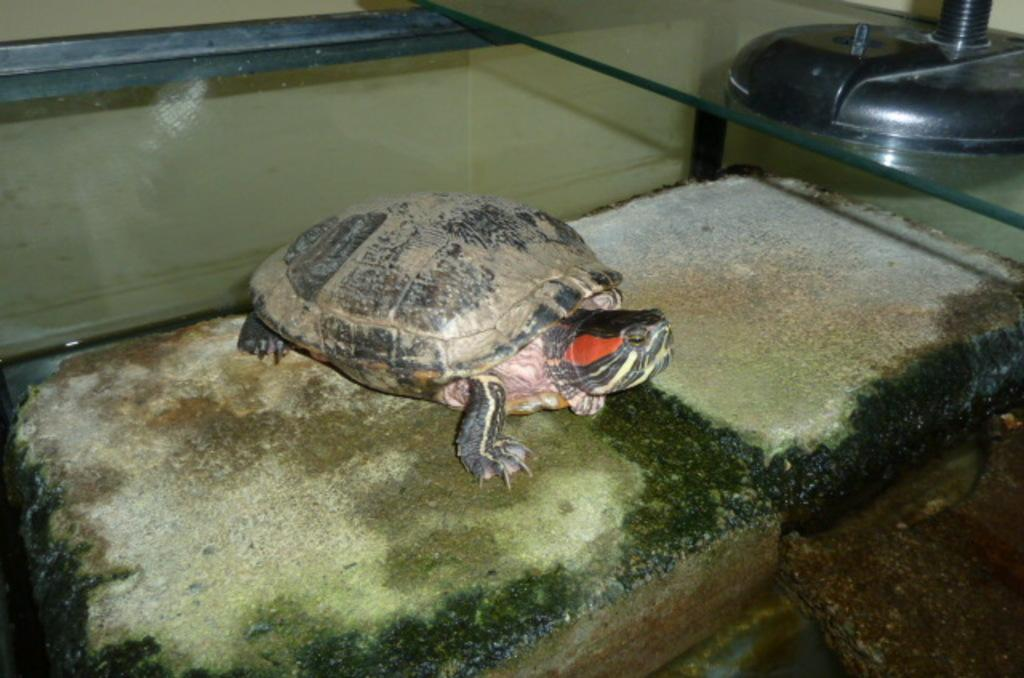What type of animal is in the image? There is a tortoise in the image. What can be seen in the background of the image? There is a wall in the background of the image. How does the tortoise transport the boy in the image? There is no boy present in the image, and the tortoise does not transport anyone. 